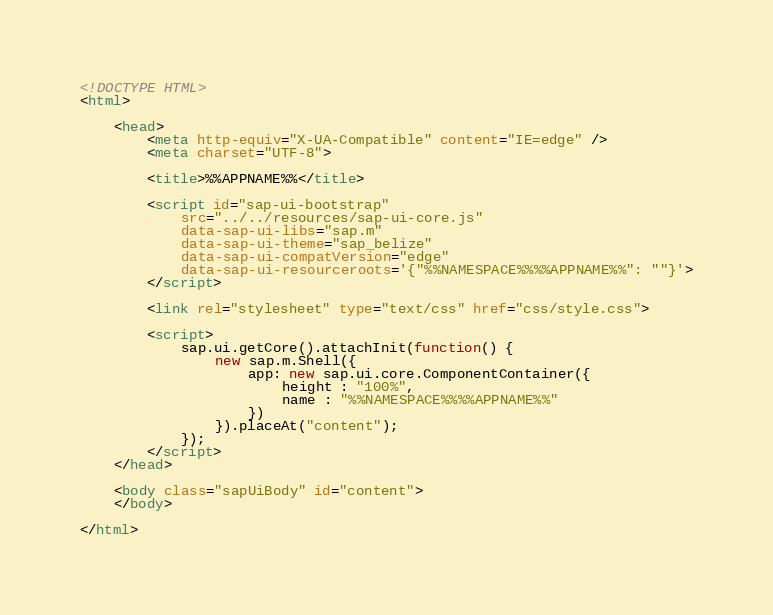Convert code to text. <code><loc_0><loc_0><loc_500><loc_500><_HTML_><!DOCTYPE HTML>
<html>

	<head>
		<meta http-equiv="X-UA-Compatible" content="IE=edge" />
		<meta charset="UTF-8">

		<title>%%APPNAME%%</title>

		<script id="sap-ui-bootstrap"
			src="../../resources/sap-ui-core.js"
			data-sap-ui-libs="sap.m"
			data-sap-ui-theme="sap_belize"
			data-sap-ui-compatVersion="edge"
			data-sap-ui-resourceroots='{"%%NAMESPACE%%%%APPNAME%%": ""}'>
		</script>

		<link rel="stylesheet" type="text/css" href="css/style.css">

		<script>
			sap.ui.getCore().attachInit(function() {
				new sap.m.Shell({
					app: new sap.ui.core.ComponentContainer({
						height : "100%",
						name : "%%NAMESPACE%%%%APPNAME%%"
					})
				}).placeAt("content");
			});
		</script>
	</head>

	<body class="sapUiBody" id="content">
	</body>

</html></code> 